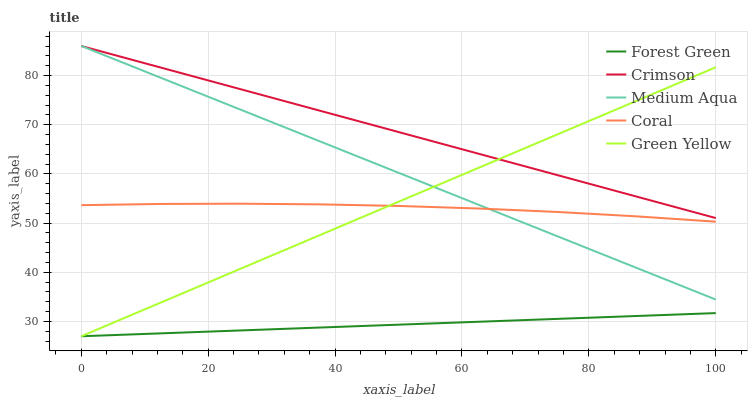Does Forest Green have the minimum area under the curve?
Answer yes or no. Yes. Does Crimson have the maximum area under the curve?
Answer yes or no. Yes. Does Green Yellow have the minimum area under the curve?
Answer yes or no. No. Does Green Yellow have the maximum area under the curve?
Answer yes or no. No. Is Green Yellow the smoothest?
Answer yes or no. Yes. Is Coral the roughest?
Answer yes or no. Yes. Is Forest Green the smoothest?
Answer yes or no. No. Is Forest Green the roughest?
Answer yes or no. No. Does Forest Green have the lowest value?
Answer yes or no. Yes. Does Medium Aqua have the lowest value?
Answer yes or no. No. Does Medium Aqua have the highest value?
Answer yes or no. Yes. Does Green Yellow have the highest value?
Answer yes or no. No. Is Forest Green less than Medium Aqua?
Answer yes or no. Yes. Is Medium Aqua greater than Forest Green?
Answer yes or no. Yes. Does Forest Green intersect Green Yellow?
Answer yes or no. Yes. Is Forest Green less than Green Yellow?
Answer yes or no. No. Is Forest Green greater than Green Yellow?
Answer yes or no. No. Does Forest Green intersect Medium Aqua?
Answer yes or no. No. 